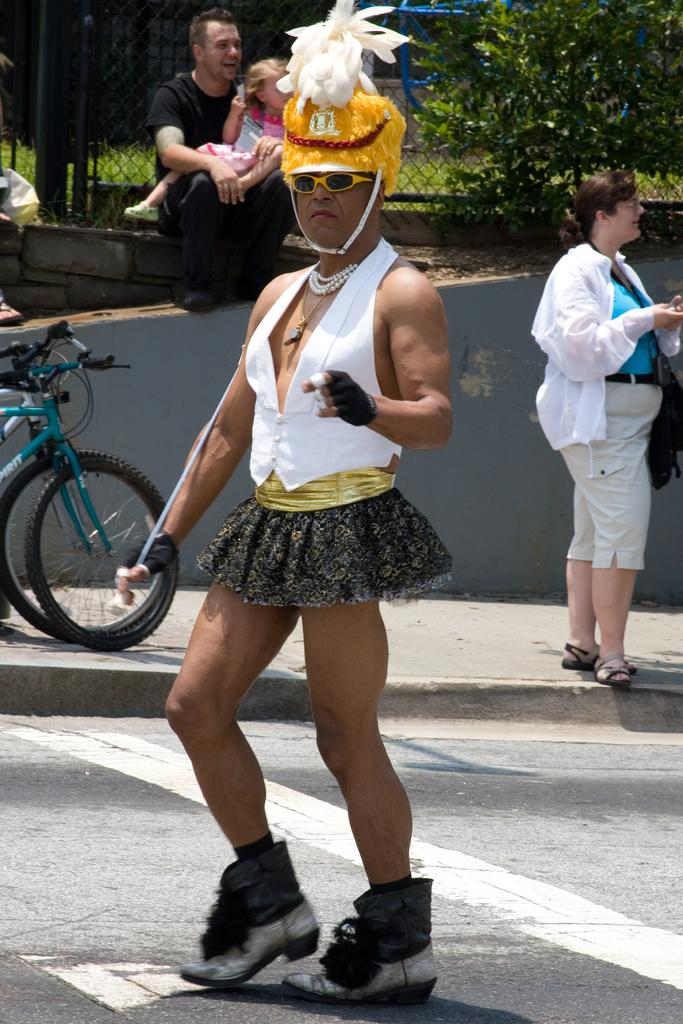What is the person in the image doing? The person in the image is walking on the road. How is the person dressed? The person is wearing a fancy dress. What is the person holding? The person is holding a stick. What can be seen in the background of the image? There are people, bicycles, a fence, leaves, a wall, grass, and a blue object in the background. What time of day is it in the image, based on the hour? The provided facts do not mention the time of day or any specific hour, so it cannot be determined from the image. 